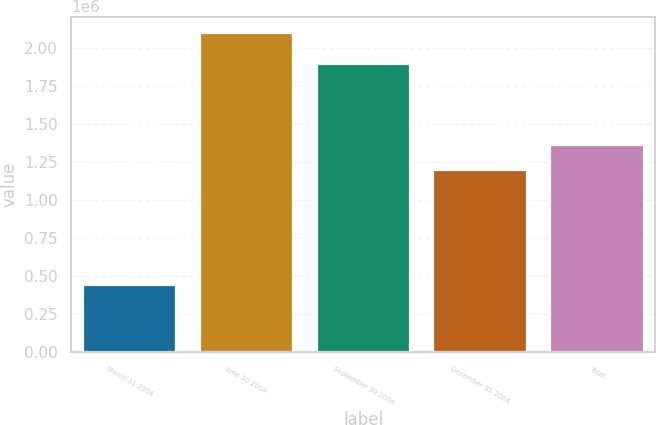Convert chart. <chart><loc_0><loc_0><loc_500><loc_500><bar_chart><fcel>March 31 2004<fcel>June 30 2004<fcel>September 30 2004<fcel>December 31 2004<fcel>Total<nl><fcel>443600<fcel>2.0989e+06<fcel>1.8953e+06<fcel>1.1954e+06<fcel>1.36093e+06<nl></chart> 